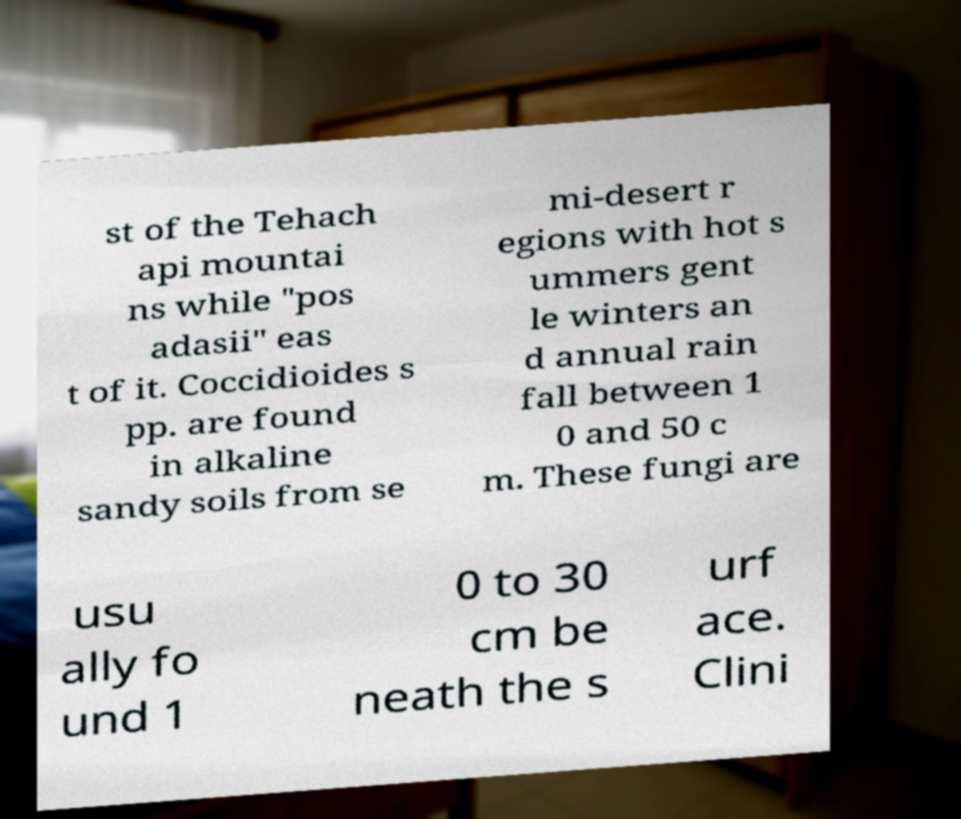Could you assist in decoding the text presented in this image and type it out clearly? st of the Tehach api mountai ns while "pos adasii" eas t of it. Coccidioides s pp. are found in alkaline sandy soils from se mi-desert r egions with hot s ummers gent le winters an d annual rain fall between 1 0 and 50 c m. These fungi are usu ally fo und 1 0 to 30 cm be neath the s urf ace. Clini 